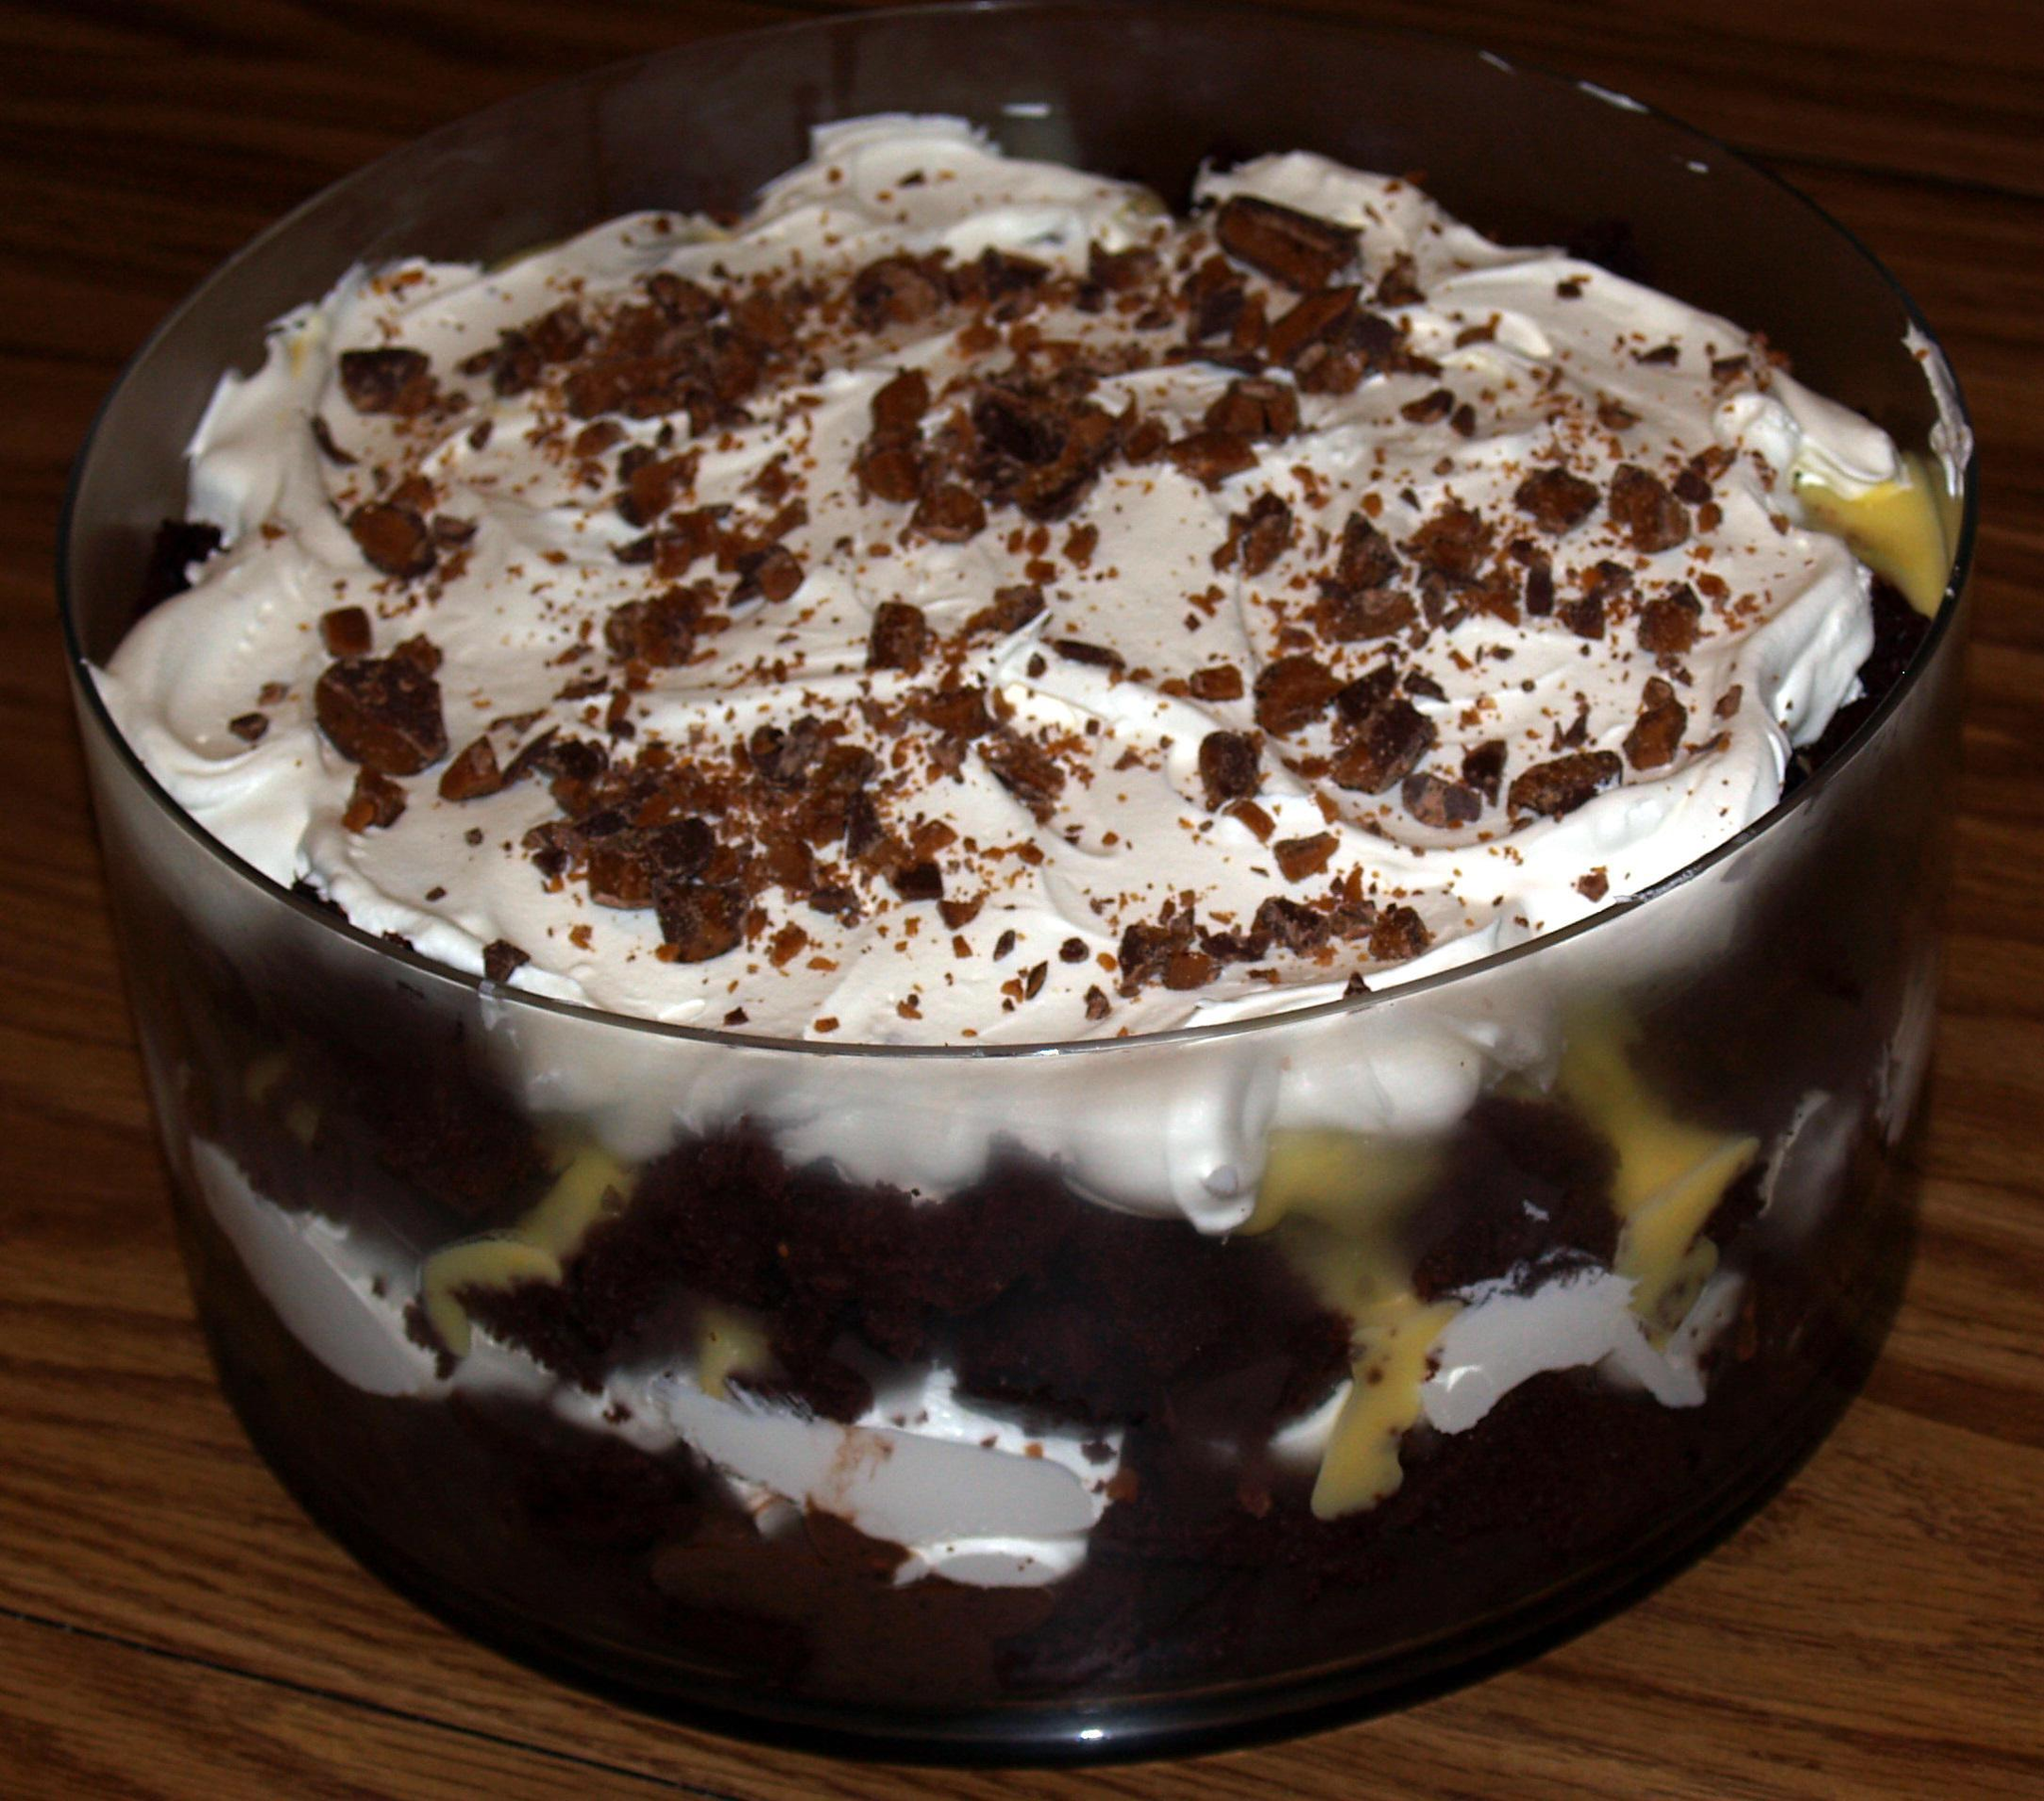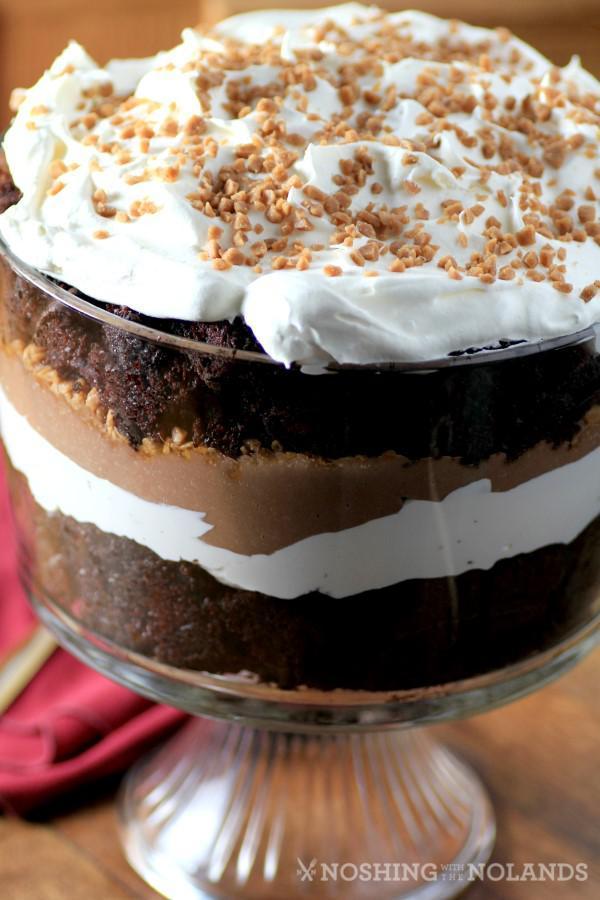The first image is the image on the left, the second image is the image on the right. Evaluate the accuracy of this statement regarding the images: "There are two desserts in one of the images". Is it true? Answer yes or no. No. The first image is the image on the left, the second image is the image on the right. For the images shown, is this caption "Two large chocolate desserts have multiple chocolate and white layers, with sprinkles in the top white layer." true? Answer yes or no. Yes. 